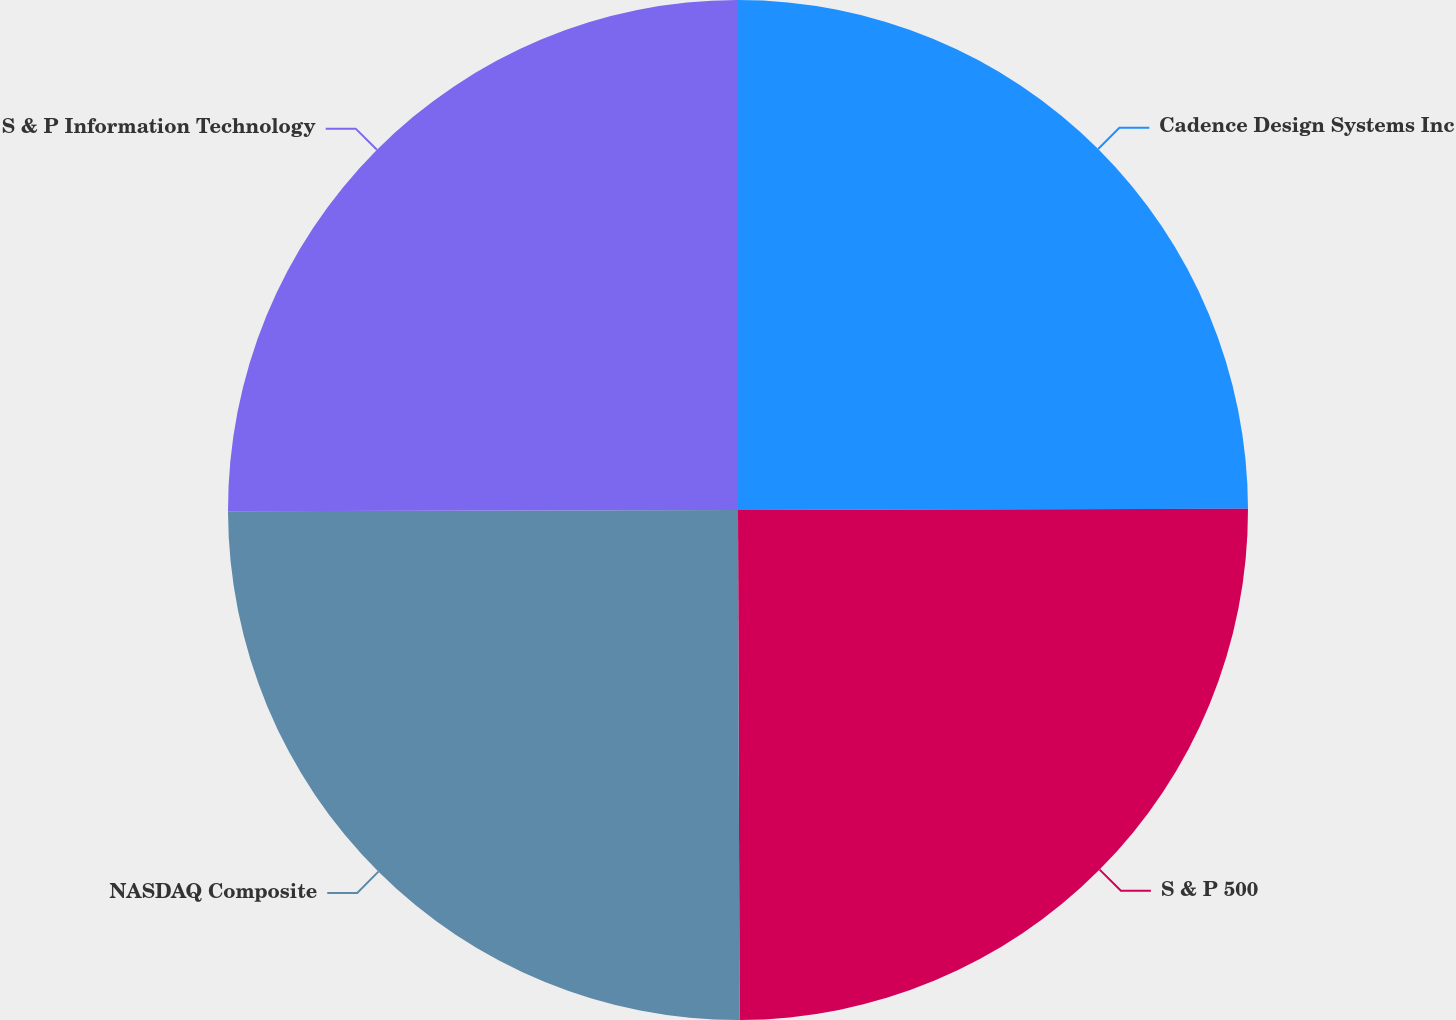<chart> <loc_0><loc_0><loc_500><loc_500><pie_chart><fcel>Cadence Design Systems Inc<fcel>S & P 500<fcel>NASDAQ Composite<fcel>S & P Information Technology<nl><fcel>24.96%<fcel>24.99%<fcel>25.01%<fcel>25.04%<nl></chart> 